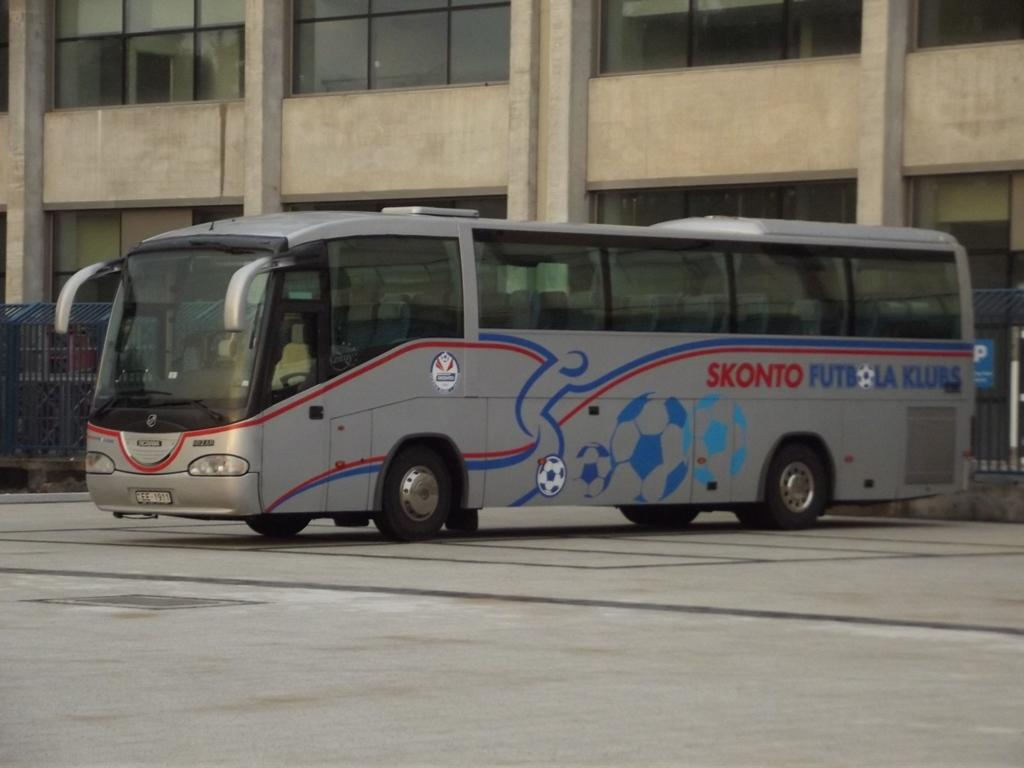What type of motor vehicle is in the image? The type of motor vehicle is not specified in the facts. Where is the motor vehicle located in the image? The motor vehicle is on the road in the image. What other objects can be seen in the image? Fences and a building are visible in the image. What type of toys are scattered on the road in the image? There are no toys mentioned or visible in the image. 